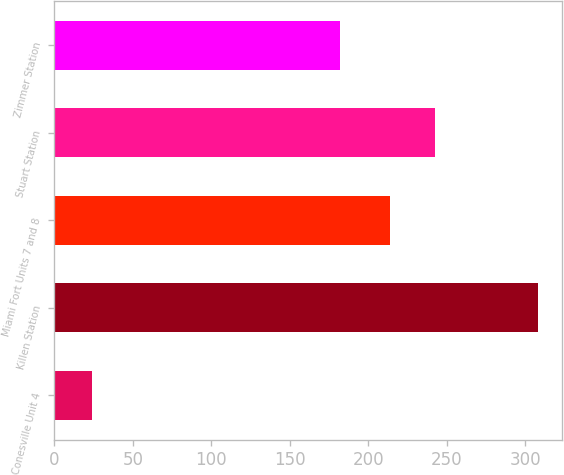Convert chart. <chart><loc_0><loc_0><loc_500><loc_500><bar_chart><fcel>Conesville Unit 4<fcel>Killen Station<fcel>Miami Fort Units 7 and 8<fcel>Stuart Station<fcel>Zimmer Station<nl><fcel>24<fcel>308<fcel>214<fcel>242.4<fcel>182<nl></chart> 